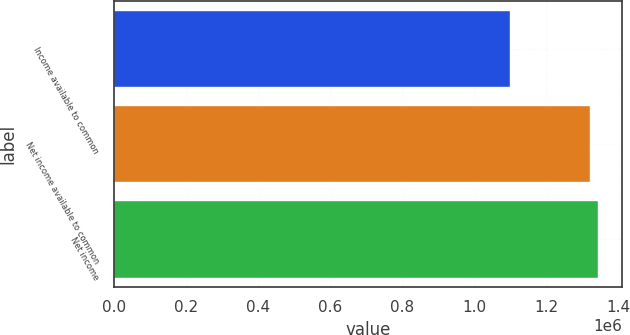<chart> <loc_0><loc_0><loc_500><loc_500><bar_chart><fcel>Income available to common<fcel>Net income available to common<fcel>Net income<nl><fcel>1.09813e+06<fcel>1.32078e+06<fcel>1.34304e+06<nl></chart> 